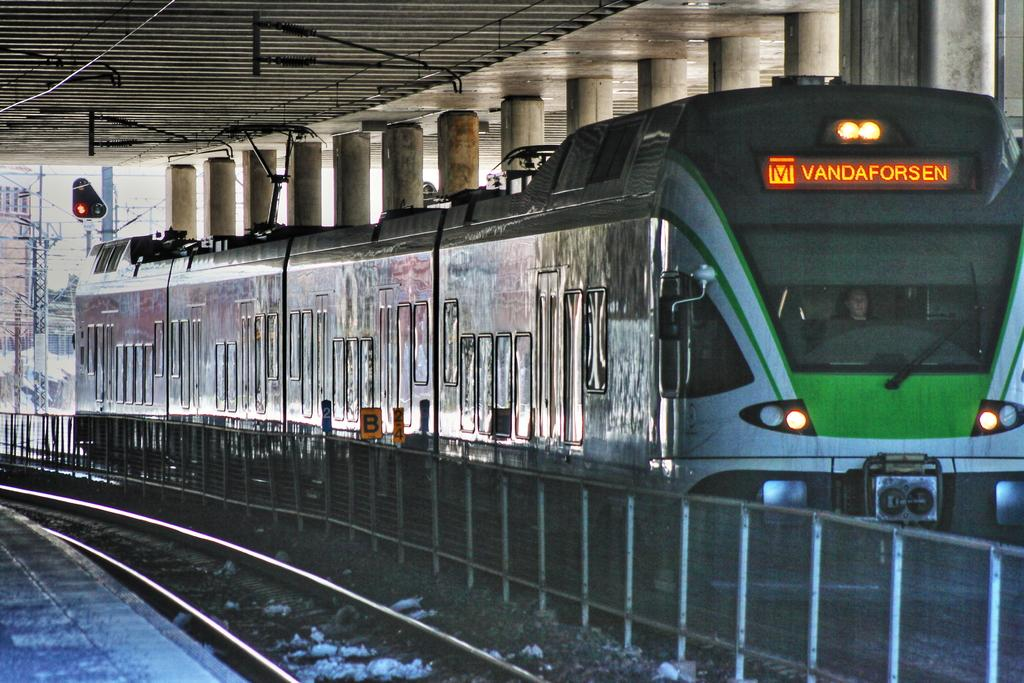What is the main subject of the image? The main subject of the image is a train. Where is the train located? The train is on a railway track. What other structures or objects can be seen in the image? There are poles, a fence, cables, lights, pillars, boards, and a platform visible in the image. What is visible in the background of the image? The sky is visible in the background of the image. What type of animal is being carried by the balloon in the image? There is no balloon or animal present in the image. How is the wax being used in the image? There is no wax present in the image. 